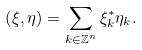Convert formula to latex. <formula><loc_0><loc_0><loc_500><loc_500>\left ( \xi , \eta \right ) = \sum _ { k \in \mathbb { Z } ^ { n } } \xi ^ { * } _ { k } \eta _ { k } .</formula> 